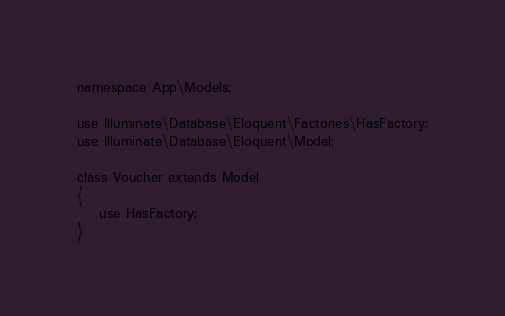Convert code to text. <code><loc_0><loc_0><loc_500><loc_500><_PHP_>namespace App\Models;

use Illuminate\Database\Eloquent\Factories\HasFactory;
use Illuminate\Database\Eloquent\Model;

class Voucher extends Model
{
    use HasFactory;
}
</code> 